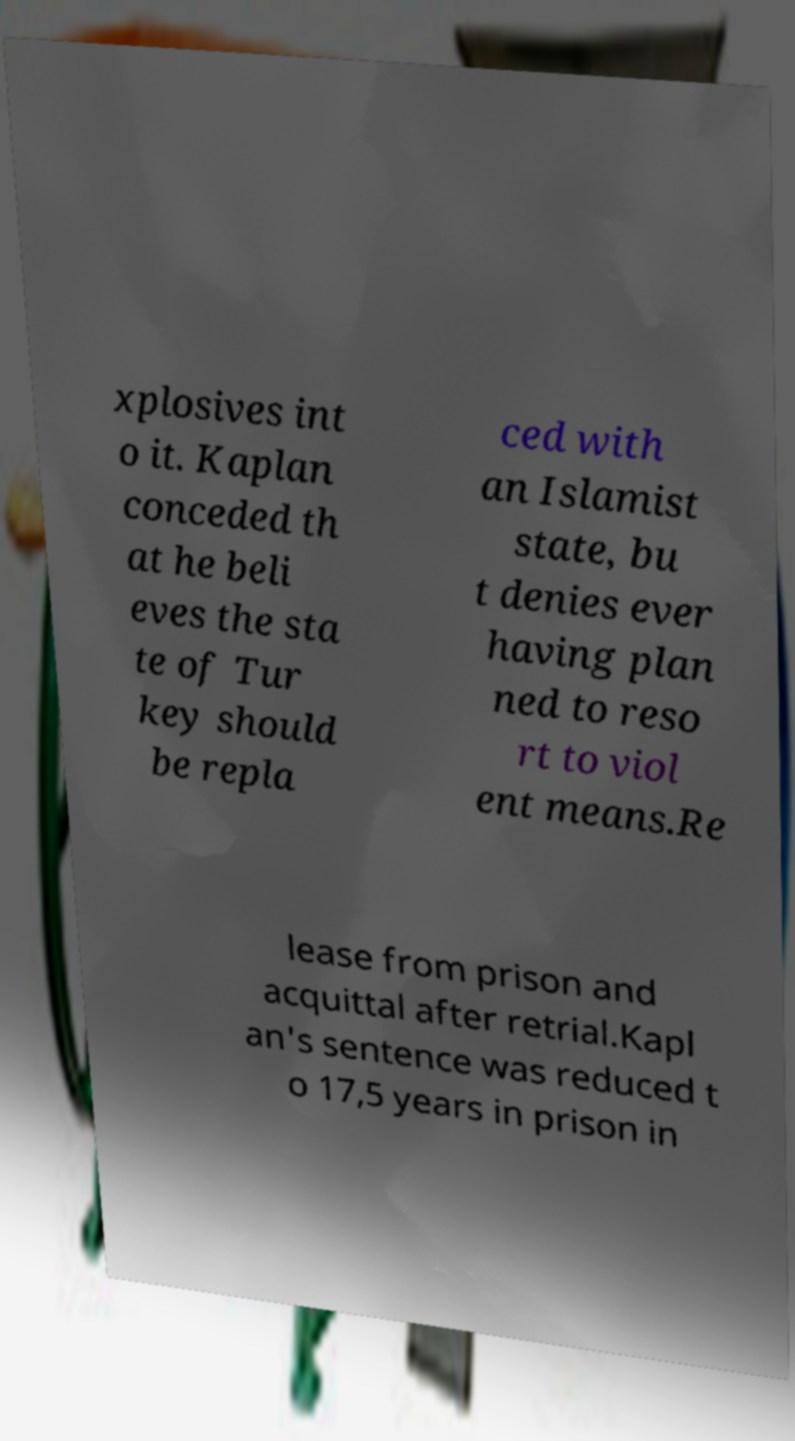I need the written content from this picture converted into text. Can you do that? xplosives int o it. Kaplan conceded th at he beli eves the sta te of Tur key should be repla ced with an Islamist state, bu t denies ever having plan ned to reso rt to viol ent means.Re lease from prison and acquittal after retrial.Kapl an's sentence was reduced t o 17,5 years in prison in 